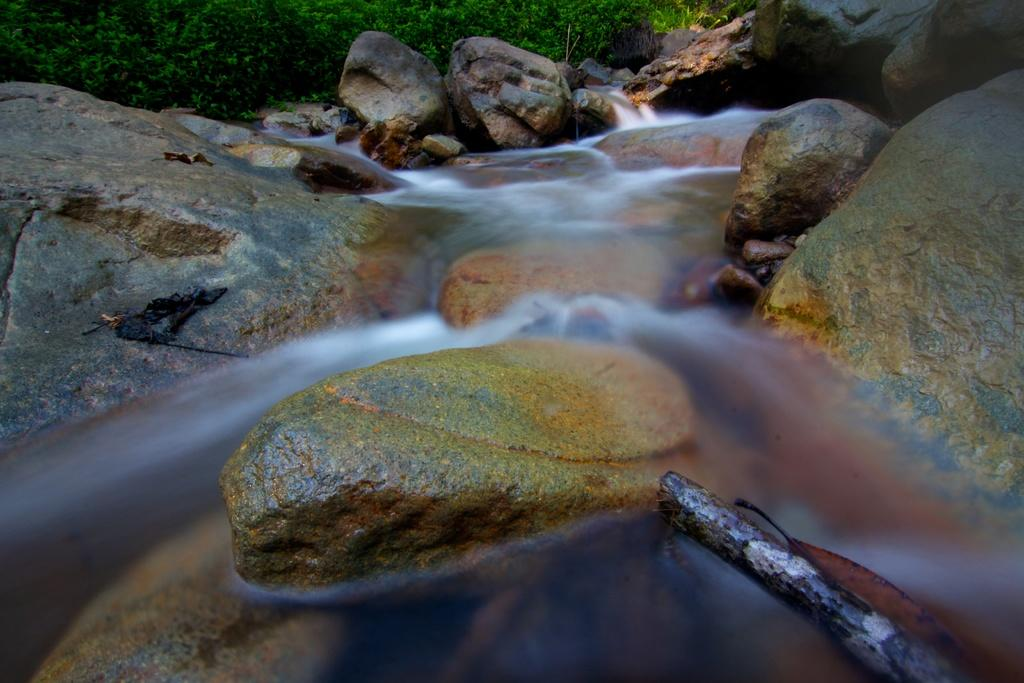What natural feature is the main subject of the image? There is a waterfall in the image. What is the waterfall situated on? The waterfall is on rocks. Can you describe the rocks behind the waterfall? There are rocks visible behind the waterfall. What type of grain can be seen growing near the waterfall in the image? There is no grain visible in the image; it features a waterfall on rocks with rocks visible behind it. Can you tell me how many zebras are grazing near the waterfall in the image? There are no zebras present in the image; it features a waterfall on rocks with rocks visible behind it. 